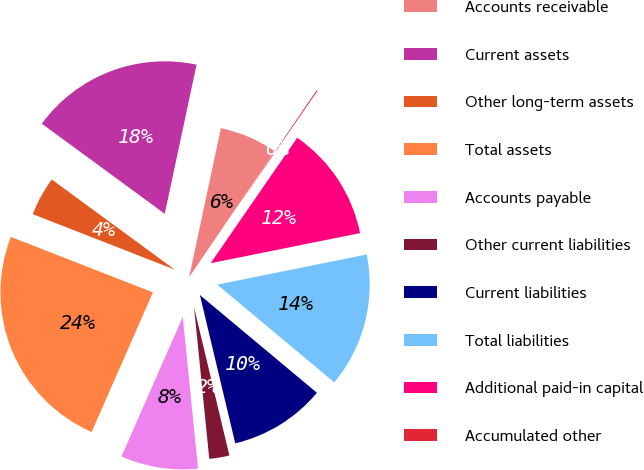Convert chart to OTSL. <chart><loc_0><loc_0><loc_500><loc_500><pie_chart><fcel>Accounts receivable<fcel>Current assets<fcel>Other long-term assets<fcel>Total assets<fcel>Accounts payable<fcel>Other current liabilities<fcel>Current liabilities<fcel>Total liabilities<fcel>Additional paid-in capital<fcel>Accumulated other<nl><fcel>6.16%<fcel>18.28%<fcel>4.14%<fcel>24.34%<fcel>8.18%<fcel>2.13%<fcel>10.2%<fcel>14.24%<fcel>12.22%<fcel>0.11%<nl></chart> 